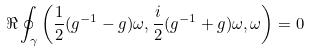<formula> <loc_0><loc_0><loc_500><loc_500>\Re \oint _ { \gamma } \left ( \frac { 1 } { 2 } ( g ^ { - 1 } - g ) \omega , \frac { i } { 2 } ( g ^ { - 1 } + g ) \omega , \omega \right ) = 0</formula> 